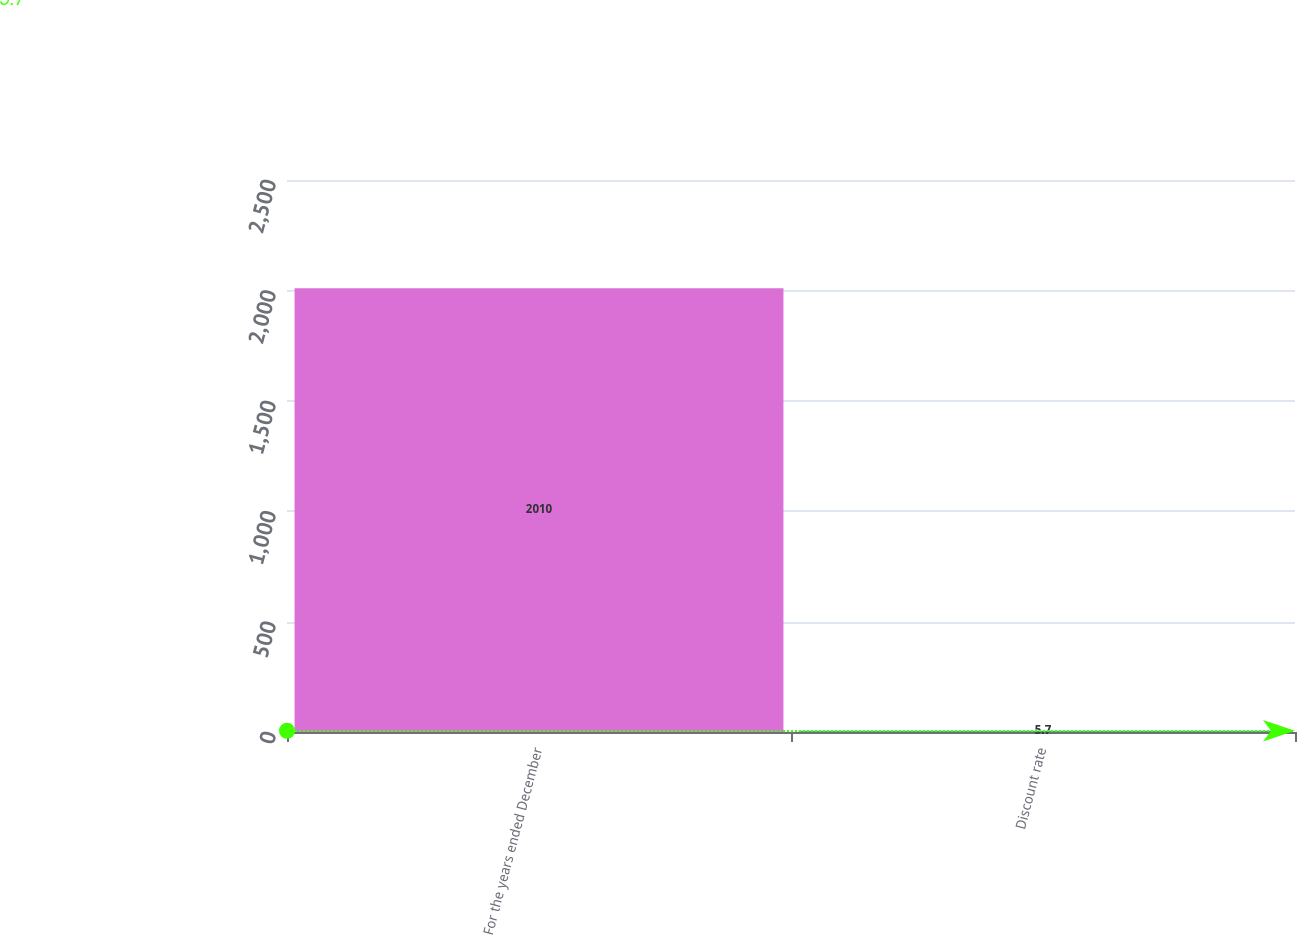<chart> <loc_0><loc_0><loc_500><loc_500><bar_chart><fcel>For the years ended December<fcel>Discount rate<nl><fcel>2010<fcel>5.7<nl></chart> 